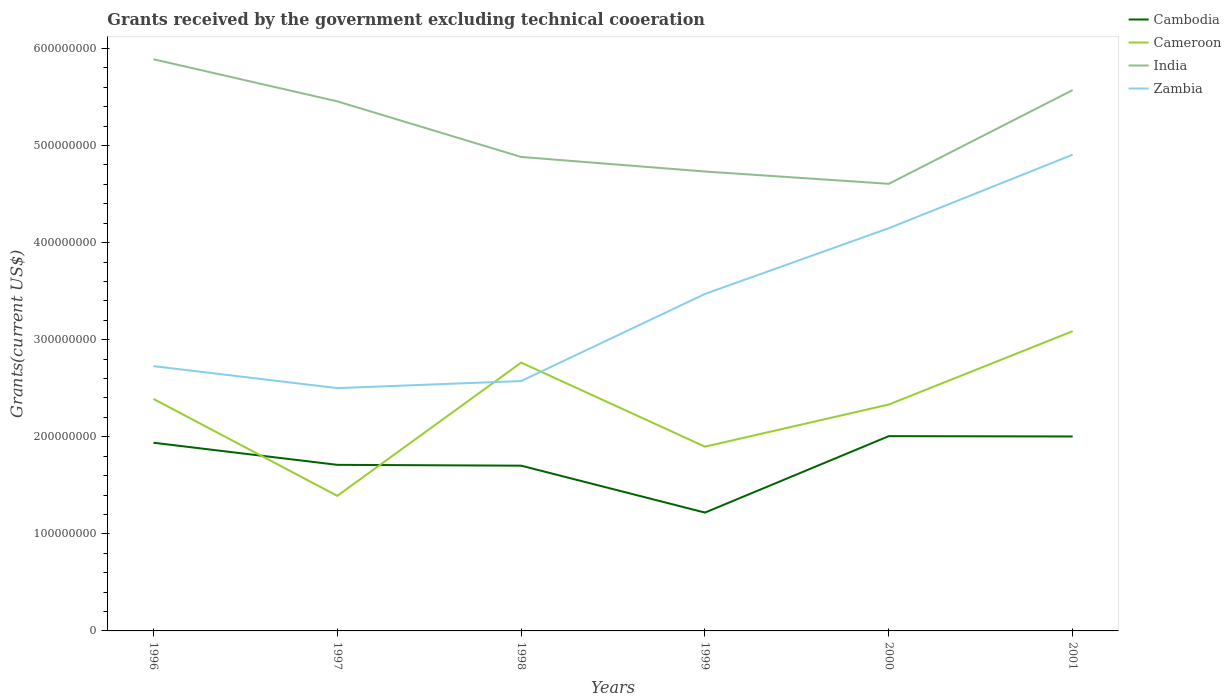How many different coloured lines are there?
Ensure brevity in your answer.  4. Does the line corresponding to India intersect with the line corresponding to Cambodia?
Provide a succinct answer. No. Across all years, what is the maximum total grants received by the government in Zambia?
Provide a short and direct response. 2.50e+08. In which year was the total grants received by the government in India maximum?
Your answer should be compact. 2000. What is the total total grants received by the government in India in the graph?
Provide a short and direct response. 8.50e+07. What is the difference between the highest and the second highest total grants received by the government in India?
Offer a very short reply. 1.28e+08. What is the difference between the highest and the lowest total grants received by the government in India?
Provide a succinct answer. 3. Is the total grants received by the government in Cameroon strictly greater than the total grants received by the government in Cambodia over the years?
Your answer should be very brief. No. How many years are there in the graph?
Offer a very short reply. 6. Where does the legend appear in the graph?
Provide a short and direct response. Top right. How many legend labels are there?
Provide a succinct answer. 4. What is the title of the graph?
Make the answer very short. Grants received by the government excluding technical cooeration. What is the label or title of the X-axis?
Your response must be concise. Years. What is the label or title of the Y-axis?
Your answer should be very brief. Grants(current US$). What is the Grants(current US$) of Cambodia in 1996?
Offer a very short reply. 1.94e+08. What is the Grants(current US$) in Cameroon in 1996?
Your answer should be compact. 2.39e+08. What is the Grants(current US$) of India in 1996?
Give a very brief answer. 5.89e+08. What is the Grants(current US$) of Zambia in 1996?
Provide a short and direct response. 2.73e+08. What is the Grants(current US$) in Cambodia in 1997?
Make the answer very short. 1.71e+08. What is the Grants(current US$) of Cameroon in 1997?
Your response must be concise. 1.39e+08. What is the Grants(current US$) of India in 1997?
Your answer should be compact. 5.46e+08. What is the Grants(current US$) of Zambia in 1997?
Your answer should be compact. 2.50e+08. What is the Grants(current US$) in Cambodia in 1998?
Offer a very short reply. 1.70e+08. What is the Grants(current US$) of Cameroon in 1998?
Keep it short and to the point. 2.76e+08. What is the Grants(current US$) in India in 1998?
Provide a succinct answer. 4.88e+08. What is the Grants(current US$) of Zambia in 1998?
Offer a very short reply. 2.57e+08. What is the Grants(current US$) in Cambodia in 1999?
Your response must be concise. 1.22e+08. What is the Grants(current US$) in Cameroon in 1999?
Your answer should be very brief. 1.90e+08. What is the Grants(current US$) of India in 1999?
Provide a succinct answer. 4.73e+08. What is the Grants(current US$) of Zambia in 1999?
Provide a short and direct response. 3.47e+08. What is the Grants(current US$) in Cambodia in 2000?
Provide a succinct answer. 2.01e+08. What is the Grants(current US$) in Cameroon in 2000?
Make the answer very short. 2.33e+08. What is the Grants(current US$) of India in 2000?
Make the answer very short. 4.61e+08. What is the Grants(current US$) in Zambia in 2000?
Offer a very short reply. 4.15e+08. What is the Grants(current US$) of Cambodia in 2001?
Give a very brief answer. 2.00e+08. What is the Grants(current US$) in Cameroon in 2001?
Provide a succinct answer. 3.09e+08. What is the Grants(current US$) of India in 2001?
Your response must be concise. 5.57e+08. What is the Grants(current US$) of Zambia in 2001?
Make the answer very short. 4.91e+08. Across all years, what is the maximum Grants(current US$) of Cambodia?
Ensure brevity in your answer.  2.01e+08. Across all years, what is the maximum Grants(current US$) of Cameroon?
Provide a short and direct response. 3.09e+08. Across all years, what is the maximum Grants(current US$) of India?
Keep it short and to the point. 5.89e+08. Across all years, what is the maximum Grants(current US$) of Zambia?
Make the answer very short. 4.91e+08. Across all years, what is the minimum Grants(current US$) in Cambodia?
Your answer should be compact. 1.22e+08. Across all years, what is the minimum Grants(current US$) of Cameroon?
Your answer should be very brief. 1.39e+08. Across all years, what is the minimum Grants(current US$) in India?
Provide a short and direct response. 4.61e+08. Across all years, what is the minimum Grants(current US$) of Zambia?
Offer a terse response. 2.50e+08. What is the total Grants(current US$) in Cambodia in the graph?
Keep it short and to the point. 1.06e+09. What is the total Grants(current US$) of Cameroon in the graph?
Give a very brief answer. 1.39e+09. What is the total Grants(current US$) in India in the graph?
Offer a very short reply. 3.11e+09. What is the total Grants(current US$) in Zambia in the graph?
Give a very brief answer. 2.03e+09. What is the difference between the Grants(current US$) of Cambodia in 1996 and that in 1997?
Your answer should be very brief. 2.28e+07. What is the difference between the Grants(current US$) of Cameroon in 1996 and that in 1997?
Provide a short and direct response. 9.99e+07. What is the difference between the Grants(current US$) of India in 1996 and that in 1997?
Offer a terse response. 4.34e+07. What is the difference between the Grants(current US$) in Zambia in 1996 and that in 1997?
Your answer should be compact. 2.27e+07. What is the difference between the Grants(current US$) of Cambodia in 1996 and that in 1998?
Give a very brief answer. 2.36e+07. What is the difference between the Grants(current US$) in Cameroon in 1996 and that in 1998?
Offer a very short reply. -3.74e+07. What is the difference between the Grants(current US$) of India in 1996 and that in 1998?
Provide a short and direct response. 1.01e+08. What is the difference between the Grants(current US$) of Zambia in 1996 and that in 1998?
Keep it short and to the point. 1.54e+07. What is the difference between the Grants(current US$) in Cambodia in 1996 and that in 1999?
Offer a very short reply. 7.20e+07. What is the difference between the Grants(current US$) in Cameroon in 1996 and that in 1999?
Your answer should be very brief. 4.92e+07. What is the difference between the Grants(current US$) of India in 1996 and that in 1999?
Make the answer very short. 1.16e+08. What is the difference between the Grants(current US$) of Zambia in 1996 and that in 1999?
Make the answer very short. -7.44e+07. What is the difference between the Grants(current US$) in Cambodia in 1996 and that in 2000?
Offer a terse response. -6.78e+06. What is the difference between the Grants(current US$) of Cameroon in 1996 and that in 2000?
Give a very brief answer. 5.79e+06. What is the difference between the Grants(current US$) of India in 1996 and that in 2000?
Give a very brief answer. 1.28e+08. What is the difference between the Grants(current US$) in Zambia in 1996 and that in 2000?
Offer a very short reply. -1.42e+08. What is the difference between the Grants(current US$) of Cambodia in 1996 and that in 2001?
Provide a short and direct response. -6.45e+06. What is the difference between the Grants(current US$) of Cameroon in 1996 and that in 2001?
Ensure brevity in your answer.  -6.98e+07. What is the difference between the Grants(current US$) in India in 1996 and that in 2001?
Provide a short and direct response. 3.18e+07. What is the difference between the Grants(current US$) in Zambia in 1996 and that in 2001?
Provide a short and direct response. -2.18e+08. What is the difference between the Grants(current US$) of Cambodia in 1997 and that in 1998?
Provide a succinct answer. 8.60e+05. What is the difference between the Grants(current US$) of Cameroon in 1997 and that in 1998?
Your answer should be compact. -1.37e+08. What is the difference between the Grants(current US$) of India in 1997 and that in 1998?
Give a very brief answer. 5.73e+07. What is the difference between the Grants(current US$) of Zambia in 1997 and that in 1998?
Offer a terse response. -7.27e+06. What is the difference between the Grants(current US$) in Cambodia in 1997 and that in 1999?
Give a very brief answer. 4.92e+07. What is the difference between the Grants(current US$) in Cameroon in 1997 and that in 1999?
Offer a very short reply. -5.07e+07. What is the difference between the Grants(current US$) of India in 1997 and that in 1999?
Make the answer very short. 7.23e+07. What is the difference between the Grants(current US$) in Zambia in 1997 and that in 1999?
Your answer should be compact. -9.70e+07. What is the difference between the Grants(current US$) of Cambodia in 1997 and that in 2000?
Make the answer very short. -2.96e+07. What is the difference between the Grants(current US$) in Cameroon in 1997 and that in 2000?
Provide a short and direct response. -9.41e+07. What is the difference between the Grants(current US$) of India in 1997 and that in 2000?
Make the answer very short. 8.50e+07. What is the difference between the Grants(current US$) in Zambia in 1997 and that in 2000?
Your answer should be very brief. -1.65e+08. What is the difference between the Grants(current US$) of Cambodia in 1997 and that in 2001?
Give a very brief answer. -2.92e+07. What is the difference between the Grants(current US$) of Cameroon in 1997 and that in 2001?
Give a very brief answer. -1.70e+08. What is the difference between the Grants(current US$) of India in 1997 and that in 2001?
Provide a short and direct response. -1.16e+07. What is the difference between the Grants(current US$) of Zambia in 1997 and that in 2001?
Your response must be concise. -2.40e+08. What is the difference between the Grants(current US$) of Cambodia in 1998 and that in 1999?
Keep it short and to the point. 4.83e+07. What is the difference between the Grants(current US$) of Cameroon in 1998 and that in 1999?
Provide a succinct answer. 8.66e+07. What is the difference between the Grants(current US$) of India in 1998 and that in 1999?
Ensure brevity in your answer.  1.50e+07. What is the difference between the Grants(current US$) in Zambia in 1998 and that in 1999?
Your response must be concise. -8.97e+07. What is the difference between the Grants(current US$) in Cambodia in 1998 and that in 2000?
Offer a very short reply. -3.04e+07. What is the difference between the Grants(current US$) in Cameroon in 1998 and that in 2000?
Offer a very short reply. 4.32e+07. What is the difference between the Grants(current US$) in India in 1998 and that in 2000?
Give a very brief answer. 2.77e+07. What is the difference between the Grants(current US$) of Zambia in 1998 and that in 2000?
Provide a short and direct response. -1.57e+08. What is the difference between the Grants(current US$) of Cambodia in 1998 and that in 2001?
Your response must be concise. -3.01e+07. What is the difference between the Grants(current US$) in Cameroon in 1998 and that in 2001?
Your response must be concise. -3.24e+07. What is the difference between the Grants(current US$) in India in 1998 and that in 2001?
Provide a short and direct response. -6.89e+07. What is the difference between the Grants(current US$) in Zambia in 1998 and that in 2001?
Keep it short and to the point. -2.33e+08. What is the difference between the Grants(current US$) of Cambodia in 1999 and that in 2000?
Provide a succinct answer. -7.87e+07. What is the difference between the Grants(current US$) of Cameroon in 1999 and that in 2000?
Offer a terse response. -4.34e+07. What is the difference between the Grants(current US$) in India in 1999 and that in 2000?
Your answer should be compact. 1.27e+07. What is the difference between the Grants(current US$) of Zambia in 1999 and that in 2000?
Offer a very short reply. -6.77e+07. What is the difference between the Grants(current US$) in Cambodia in 1999 and that in 2001?
Offer a terse response. -7.84e+07. What is the difference between the Grants(current US$) in Cameroon in 1999 and that in 2001?
Your response must be concise. -1.19e+08. What is the difference between the Grants(current US$) in India in 1999 and that in 2001?
Offer a terse response. -8.39e+07. What is the difference between the Grants(current US$) of Zambia in 1999 and that in 2001?
Your answer should be very brief. -1.43e+08. What is the difference between the Grants(current US$) of Cameroon in 2000 and that in 2001?
Provide a short and direct response. -7.55e+07. What is the difference between the Grants(current US$) in India in 2000 and that in 2001?
Your response must be concise. -9.66e+07. What is the difference between the Grants(current US$) of Zambia in 2000 and that in 2001?
Provide a succinct answer. -7.58e+07. What is the difference between the Grants(current US$) in Cambodia in 1996 and the Grants(current US$) in Cameroon in 1997?
Ensure brevity in your answer.  5.47e+07. What is the difference between the Grants(current US$) of Cambodia in 1996 and the Grants(current US$) of India in 1997?
Your response must be concise. -3.52e+08. What is the difference between the Grants(current US$) in Cambodia in 1996 and the Grants(current US$) in Zambia in 1997?
Ensure brevity in your answer.  -5.63e+07. What is the difference between the Grants(current US$) in Cameroon in 1996 and the Grants(current US$) in India in 1997?
Keep it short and to the point. -3.07e+08. What is the difference between the Grants(current US$) of Cameroon in 1996 and the Grants(current US$) of Zambia in 1997?
Make the answer very short. -1.11e+07. What is the difference between the Grants(current US$) in India in 1996 and the Grants(current US$) in Zambia in 1997?
Your answer should be very brief. 3.39e+08. What is the difference between the Grants(current US$) of Cambodia in 1996 and the Grants(current US$) of Cameroon in 1998?
Make the answer very short. -8.25e+07. What is the difference between the Grants(current US$) of Cambodia in 1996 and the Grants(current US$) of India in 1998?
Your response must be concise. -2.94e+08. What is the difference between the Grants(current US$) in Cambodia in 1996 and the Grants(current US$) in Zambia in 1998?
Offer a terse response. -6.35e+07. What is the difference between the Grants(current US$) in Cameroon in 1996 and the Grants(current US$) in India in 1998?
Provide a succinct answer. -2.49e+08. What is the difference between the Grants(current US$) in Cameroon in 1996 and the Grants(current US$) in Zambia in 1998?
Ensure brevity in your answer.  -1.84e+07. What is the difference between the Grants(current US$) of India in 1996 and the Grants(current US$) of Zambia in 1998?
Make the answer very short. 3.32e+08. What is the difference between the Grants(current US$) in Cambodia in 1996 and the Grants(current US$) in Cameroon in 1999?
Offer a terse response. 4.06e+06. What is the difference between the Grants(current US$) in Cambodia in 1996 and the Grants(current US$) in India in 1999?
Your response must be concise. -2.79e+08. What is the difference between the Grants(current US$) of Cambodia in 1996 and the Grants(current US$) of Zambia in 1999?
Your answer should be very brief. -1.53e+08. What is the difference between the Grants(current US$) in Cameroon in 1996 and the Grants(current US$) in India in 1999?
Provide a short and direct response. -2.34e+08. What is the difference between the Grants(current US$) of Cameroon in 1996 and the Grants(current US$) of Zambia in 1999?
Provide a succinct answer. -1.08e+08. What is the difference between the Grants(current US$) in India in 1996 and the Grants(current US$) in Zambia in 1999?
Keep it short and to the point. 2.42e+08. What is the difference between the Grants(current US$) in Cambodia in 1996 and the Grants(current US$) in Cameroon in 2000?
Your answer should be very brief. -3.94e+07. What is the difference between the Grants(current US$) of Cambodia in 1996 and the Grants(current US$) of India in 2000?
Offer a terse response. -2.67e+08. What is the difference between the Grants(current US$) in Cambodia in 1996 and the Grants(current US$) in Zambia in 2000?
Offer a terse response. -2.21e+08. What is the difference between the Grants(current US$) in Cameroon in 1996 and the Grants(current US$) in India in 2000?
Keep it short and to the point. -2.22e+08. What is the difference between the Grants(current US$) in Cameroon in 1996 and the Grants(current US$) in Zambia in 2000?
Provide a succinct answer. -1.76e+08. What is the difference between the Grants(current US$) of India in 1996 and the Grants(current US$) of Zambia in 2000?
Offer a terse response. 1.74e+08. What is the difference between the Grants(current US$) of Cambodia in 1996 and the Grants(current US$) of Cameroon in 2001?
Your answer should be compact. -1.15e+08. What is the difference between the Grants(current US$) in Cambodia in 1996 and the Grants(current US$) in India in 2001?
Your response must be concise. -3.63e+08. What is the difference between the Grants(current US$) of Cambodia in 1996 and the Grants(current US$) of Zambia in 2001?
Give a very brief answer. -2.97e+08. What is the difference between the Grants(current US$) of Cameroon in 1996 and the Grants(current US$) of India in 2001?
Make the answer very short. -3.18e+08. What is the difference between the Grants(current US$) of Cameroon in 1996 and the Grants(current US$) of Zambia in 2001?
Provide a short and direct response. -2.52e+08. What is the difference between the Grants(current US$) in India in 1996 and the Grants(current US$) in Zambia in 2001?
Offer a very short reply. 9.83e+07. What is the difference between the Grants(current US$) in Cambodia in 1997 and the Grants(current US$) in Cameroon in 1998?
Offer a very short reply. -1.05e+08. What is the difference between the Grants(current US$) in Cambodia in 1997 and the Grants(current US$) in India in 1998?
Provide a succinct answer. -3.17e+08. What is the difference between the Grants(current US$) of Cambodia in 1997 and the Grants(current US$) of Zambia in 1998?
Ensure brevity in your answer.  -8.63e+07. What is the difference between the Grants(current US$) in Cameroon in 1997 and the Grants(current US$) in India in 1998?
Your response must be concise. -3.49e+08. What is the difference between the Grants(current US$) of Cameroon in 1997 and the Grants(current US$) of Zambia in 1998?
Offer a terse response. -1.18e+08. What is the difference between the Grants(current US$) in India in 1997 and the Grants(current US$) in Zambia in 1998?
Ensure brevity in your answer.  2.88e+08. What is the difference between the Grants(current US$) in Cambodia in 1997 and the Grants(current US$) in Cameroon in 1999?
Provide a short and direct response. -1.87e+07. What is the difference between the Grants(current US$) of Cambodia in 1997 and the Grants(current US$) of India in 1999?
Give a very brief answer. -3.02e+08. What is the difference between the Grants(current US$) in Cambodia in 1997 and the Grants(current US$) in Zambia in 1999?
Ensure brevity in your answer.  -1.76e+08. What is the difference between the Grants(current US$) of Cameroon in 1997 and the Grants(current US$) of India in 1999?
Make the answer very short. -3.34e+08. What is the difference between the Grants(current US$) of Cameroon in 1997 and the Grants(current US$) of Zambia in 1999?
Offer a terse response. -2.08e+08. What is the difference between the Grants(current US$) of India in 1997 and the Grants(current US$) of Zambia in 1999?
Offer a very short reply. 1.98e+08. What is the difference between the Grants(current US$) in Cambodia in 1997 and the Grants(current US$) in Cameroon in 2000?
Offer a very short reply. -6.21e+07. What is the difference between the Grants(current US$) of Cambodia in 1997 and the Grants(current US$) of India in 2000?
Provide a succinct answer. -2.90e+08. What is the difference between the Grants(current US$) in Cambodia in 1997 and the Grants(current US$) in Zambia in 2000?
Ensure brevity in your answer.  -2.44e+08. What is the difference between the Grants(current US$) of Cameroon in 1997 and the Grants(current US$) of India in 2000?
Your answer should be compact. -3.21e+08. What is the difference between the Grants(current US$) in Cameroon in 1997 and the Grants(current US$) in Zambia in 2000?
Ensure brevity in your answer.  -2.76e+08. What is the difference between the Grants(current US$) in India in 1997 and the Grants(current US$) in Zambia in 2000?
Your response must be concise. 1.31e+08. What is the difference between the Grants(current US$) of Cambodia in 1997 and the Grants(current US$) of Cameroon in 2001?
Provide a succinct answer. -1.38e+08. What is the difference between the Grants(current US$) in Cambodia in 1997 and the Grants(current US$) in India in 2001?
Keep it short and to the point. -3.86e+08. What is the difference between the Grants(current US$) of Cambodia in 1997 and the Grants(current US$) of Zambia in 2001?
Provide a succinct answer. -3.20e+08. What is the difference between the Grants(current US$) in Cameroon in 1997 and the Grants(current US$) in India in 2001?
Your answer should be very brief. -4.18e+08. What is the difference between the Grants(current US$) of Cameroon in 1997 and the Grants(current US$) of Zambia in 2001?
Your answer should be compact. -3.51e+08. What is the difference between the Grants(current US$) in India in 1997 and the Grants(current US$) in Zambia in 2001?
Keep it short and to the point. 5.49e+07. What is the difference between the Grants(current US$) in Cambodia in 1998 and the Grants(current US$) in Cameroon in 1999?
Make the answer very short. -1.96e+07. What is the difference between the Grants(current US$) of Cambodia in 1998 and the Grants(current US$) of India in 1999?
Offer a terse response. -3.03e+08. What is the difference between the Grants(current US$) of Cambodia in 1998 and the Grants(current US$) of Zambia in 1999?
Make the answer very short. -1.77e+08. What is the difference between the Grants(current US$) in Cameroon in 1998 and the Grants(current US$) in India in 1999?
Offer a terse response. -1.97e+08. What is the difference between the Grants(current US$) of Cameroon in 1998 and the Grants(current US$) of Zambia in 1999?
Your answer should be compact. -7.07e+07. What is the difference between the Grants(current US$) in India in 1998 and the Grants(current US$) in Zambia in 1999?
Your response must be concise. 1.41e+08. What is the difference between the Grants(current US$) of Cambodia in 1998 and the Grants(current US$) of Cameroon in 2000?
Provide a short and direct response. -6.30e+07. What is the difference between the Grants(current US$) of Cambodia in 1998 and the Grants(current US$) of India in 2000?
Make the answer very short. -2.90e+08. What is the difference between the Grants(current US$) of Cambodia in 1998 and the Grants(current US$) of Zambia in 2000?
Make the answer very short. -2.45e+08. What is the difference between the Grants(current US$) of Cameroon in 1998 and the Grants(current US$) of India in 2000?
Offer a very short reply. -1.84e+08. What is the difference between the Grants(current US$) of Cameroon in 1998 and the Grants(current US$) of Zambia in 2000?
Your answer should be compact. -1.38e+08. What is the difference between the Grants(current US$) of India in 1998 and the Grants(current US$) of Zambia in 2000?
Offer a very short reply. 7.34e+07. What is the difference between the Grants(current US$) in Cambodia in 1998 and the Grants(current US$) in Cameroon in 2001?
Provide a short and direct response. -1.39e+08. What is the difference between the Grants(current US$) of Cambodia in 1998 and the Grants(current US$) of India in 2001?
Offer a very short reply. -3.87e+08. What is the difference between the Grants(current US$) of Cambodia in 1998 and the Grants(current US$) of Zambia in 2001?
Make the answer very short. -3.20e+08. What is the difference between the Grants(current US$) of Cameroon in 1998 and the Grants(current US$) of India in 2001?
Keep it short and to the point. -2.81e+08. What is the difference between the Grants(current US$) in Cameroon in 1998 and the Grants(current US$) in Zambia in 2001?
Your answer should be compact. -2.14e+08. What is the difference between the Grants(current US$) in India in 1998 and the Grants(current US$) in Zambia in 2001?
Offer a very short reply. -2.36e+06. What is the difference between the Grants(current US$) in Cambodia in 1999 and the Grants(current US$) in Cameroon in 2000?
Ensure brevity in your answer.  -1.11e+08. What is the difference between the Grants(current US$) of Cambodia in 1999 and the Grants(current US$) of India in 2000?
Your response must be concise. -3.39e+08. What is the difference between the Grants(current US$) in Cambodia in 1999 and the Grants(current US$) in Zambia in 2000?
Your answer should be compact. -2.93e+08. What is the difference between the Grants(current US$) in Cameroon in 1999 and the Grants(current US$) in India in 2000?
Make the answer very short. -2.71e+08. What is the difference between the Grants(current US$) in Cameroon in 1999 and the Grants(current US$) in Zambia in 2000?
Your answer should be compact. -2.25e+08. What is the difference between the Grants(current US$) in India in 1999 and the Grants(current US$) in Zambia in 2000?
Provide a succinct answer. 5.84e+07. What is the difference between the Grants(current US$) in Cambodia in 1999 and the Grants(current US$) in Cameroon in 2001?
Offer a very short reply. -1.87e+08. What is the difference between the Grants(current US$) in Cambodia in 1999 and the Grants(current US$) in India in 2001?
Ensure brevity in your answer.  -4.35e+08. What is the difference between the Grants(current US$) in Cambodia in 1999 and the Grants(current US$) in Zambia in 2001?
Offer a very short reply. -3.69e+08. What is the difference between the Grants(current US$) in Cameroon in 1999 and the Grants(current US$) in India in 2001?
Offer a terse response. -3.67e+08. What is the difference between the Grants(current US$) of Cameroon in 1999 and the Grants(current US$) of Zambia in 2001?
Your response must be concise. -3.01e+08. What is the difference between the Grants(current US$) of India in 1999 and the Grants(current US$) of Zambia in 2001?
Offer a very short reply. -1.74e+07. What is the difference between the Grants(current US$) in Cambodia in 2000 and the Grants(current US$) in Cameroon in 2001?
Keep it short and to the point. -1.08e+08. What is the difference between the Grants(current US$) of Cambodia in 2000 and the Grants(current US$) of India in 2001?
Your answer should be very brief. -3.57e+08. What is the difference between the Grants(current US$) of Cambodia in 2000 and the Grants(current US$) of Zambia in 2001?
Ensure brevity in your answer.  -2.90e+08. What is the difference between the Grants(current US$) of Cameroon in 2000 and the Grants(current US$) of India in 2001?
Offer a very short reply. -3.24e+08. What is the difference between the Grants(current US$) in Cameroon in 2000 and the Grants(current US$) in Zambia in 2001?
Provide a short and direct response. -2.57e+08. What is the difference between the Grants(current US$) in India in 2000 and the Grants(current US$) in Zambia in 2001?
Make the answer very short. -3.00e+07. What is the average Grants(current US$) of Cambodia per year?
Your answer should be compact. 1.76e+08. What is the average Grants(current US$) in Cameroon per year?
Offer a very short reply. 2.31e+08. What is the average Grants(current US$) of India per year?
Keep it short and to the point. 5.19e+08. What is the average Grants(current US$) in Zambia per year?
Provide a succinct answer. 3.39e+08. In the year 1996, what is the difference between the Grants(current US$) in Cambodia and Grants(current US$) in Cameroon?
Offer a terse response. -4.51e+07. In the year 1996, what is the difference between the Grants(current US$) in Cambodia and Grants(current US$) in India?
Your response must be concise. -3.95e+08. In the year 1996, what is the difference between the Grants(current US$) in Cambodia and Grants(current US$) in Zambia?
Provide a succinct answer. -7.89e+07. In the year 1996, what is the difference between the Grants(current US$) of Cameroon and Grants(current US$) of India?
Ensure brevity in your answer.  -3.50e+08. In the year 1996, what is the difference between the Grants(current US$) of Cameroon and Grants(current US$) of Zambia?
Give a very brief answer. -3.38e+07. In the year 1996, what is the difference between the Grants(current US$) in India and Grants(current US$) in Zambia?
Give a very brief answer. 3.16e+08. In the year 1997, what is the difference between the Grants(current US$) in Cambodia and Grants(current US$) in Cameroon?
Provide a short and direct response. 3.19e+07. In the year 1997, what is the difference between the Grants(current US$) of Cambodia and Grants(current US$) of India?
Give a very brief answer. -3.74e+08. In the year 1997, what is the difference between the Grants(current US$) of Cambodia and Grants(current US$) of Zambia?
Your answer should be compact. -7.90e+07. In the year 1997, what is the difference between the Grants(current US$) in Cameroon and Grants(current US$) in India?
Your answer should be compact. -4.06e+08. In the year 1997, what is the difference between the Grants(current US$) in Cameroon and Grants(current US$) in Zambia?
Give a very brief answer. -1.11e+08. In the year 1997, what is the difference between the Grants(current US$) of India and Grants(current US$) of Zambia?
Ensure brevity in your answer.  2.95e+08. In the year 1998, what is the difference between the Grants(current US$) of Cambodia and Grants(current US$) of Cameroon?
Offer a very short reply. -1.06e+08. In the year 1998, what is the difference between the Grants(current US$) in Cambodia and Grants(current US$) in India?
Your answer should be compact. -3.18e+08. In the year 1998, what is the difference between the Grants(current US$) of Cambodia and Grants(current US$) of Zambia?
Make the answer very short. -8.72e+07. In the year 1998, what is the difference between the Grants(current US$) of Cameroon and Grants(current US$) of India?
Your answer should be very brief. -2.12e+08. In the year 1998, what is the difference between the Grants(current US$) of Cameroon and Grants(current US$) of Zambia?
Provide a succinct answer. 1.90e+07. In the year 1998, what is the difference between the Grants(current US$) of India and Grants(current US$) of Zambia?
Give a very brief answer. 2.31e+08. In the year 1999, what is the difference between the Grants(current US$) in Cambodia and Grants(current US$) in Cameroon?
Keep it short and to the point. -6.79e+07. In the year 1999, what is the difference between the Grants(current US$) of Cambodia and Grants(current US$) of India?
Provide a short and direct response. -3.51e+08. In the year 1999, what is the difference between the Grants(current US$) in Cambodia and Grants(current US$) in Zambia?
Make the answer very short. -2.25e+08. In the year 1999, what is the difference between the Grants(current US$) in Cameroon and Grants(current US$) in India?
Your response must be concise. -2.83e+08. In the year 1999, what is the difference between the Grants(current US$) of Cameroon and Grants(current US$) of Zambia?
Your response must be concise. -1.57e+08. In the year 1999, what is the difference between the Grants(current US$) of India and Grants(current US$) of Zambia?
Offer a very short reply. 1.26e+08. In the year 2000, what is the difference between the Grants(current US$) of Cambodia and Grants(current US$) of Cameroon?
Offer a very short reply. -3.26e+07. In the year 2000, what is the difference between the Grants(current US$) in Cambodia and Grants(current US$) in India?
Offer a very short reply. -2.60e+08. In the year 2000, what is the difference between the Grants(current US$) in Cambodia and Grants(current US$) in Zambia?
Give a very brief answer. -2.14e+08. In the year 2000, what is the difference between the Grants(current US$) of Cameroon and Grants(current US$) of India?
Your answer should be very brief. -2.27e+08. In the year 2000, what is the difference between the Grants(current US$) in Cameroon and Grants(current US$) in Zambia?
Offer a terse response. -1.82e+08. In the year 2000, what is the difference between the Grants(current US$) of India and Grants(current US$) of Zambia?
Offer a terse response. 4.57e+07. In the year 2001, what is the difference between the Grants(current US$) of Cambodia and Grants(current US$) of Cameroon?
Offer a terse response. -1.08e+08. In the year 2001, what is the difference between the Grants(current US$) in Cambodia and Grants(current US$) in India?
Give a very brief answer. -3.57e+08. In the year 2001, what is the difference between the Grants(current US$) of Cambodia and Grants(current US$) of Zambia?
Your answer should be very brief. -2.90e+08. In the year 2001, what is the difference between the Grants(current US$) in Cameroon and Grants(current US$) in India?
Give a very brief answer. -2.48e+08. In the year 2001, what is the difference between the Grants(current US$) of Cameroon and Grants(current US$) of Zambia?
Your answer should be very brief. -1.82e+08. In the year 2001, what is the difference between the Grants(current US$) of India and Grants(current US$) of Zambia?
Your answer should be very brief. 6.65e+07. What is the ratio of the Grants(current US$) in Cambodia in 1996 to that in 1997?
Offer a very short reply. 1.13. What is the ratio of the Grants(current US$) in Cameroon in 1996 to that in 1997?
Offer a very short reply. 1.72. What is the ratio of the Grants(current US$) of India in 1996 to that in 1997?
Your answer should be compact. 1.08. What is the ratio of the Grants(current US$) of Zambia in 1996 to that in 1997?
Offer a very short reply. 1.09. What is the ratio of the Grants(current US$) in Cambodia in 1996 to that in 1998?
Offer a very short reply. 1.14. What is the ratio of the Grants(current US$) of Cameroon in 1996 to that in 1998?
Your response must be concise. 0.86. What is the ratio of the Grants(current US$) of India in 1996 to that in 1998?
Keep it short and to the point. 1.21. What is the ratio of the Grants(current US$) of Zambia in 1996 to that in 1998?
Your response must be concise. 1.06. What is the ratio of the Grants(current US$) of Cambodia in 1996 to that in 1999?
Offer a terse response. 1.59. What is the ratio of the Grants(current US$) in Cameroon in 1996 to that in 1999?
Make the answer very short. 1.26. What is the ratio of the Grants(current US$) in India in 1996 to that in 1999?
Your answer should be compact. 1.24. What is the ratio of the Grants(current US$) in Zambia in 1996 to that in 1999?
Keep it short and to the point. 0.79. What is the ratio of the Grants(current US$) in Cambodia in 1996 to that in 2000?
Give a very brief answer. 0.97. What is the ratio of the Grants(current US$) of Cameroon in 1996 to that in 2000?
Offer a terse response. 1.02. What is the ratio of the Grants(current US$) of India in 1996 to that in 2000?
Your answer should be compact. 1.28. What is the ratio of the Grants(current US$) of Zambia in 1996 to that in 2000?
Give a very brief answer. 0.66. What is the ratio of the Grants(current US$) in Cambodia in 1996 to that in 2001?
Offer a terse response. 0.97. What is the ratio of the Grants(current US$) of Cameroon in 1996 to that in 2001?
Ensure brevity in your answer.  0.77. What is the ratio of the Grants(current US$) in India in 1996 to that in 2001?
Make the answer very short. 1.06. What is the ratio of the Grants(current US$) in Zambia in 1996 to that in 2001?
Your response must be concise. 0.56. What is the ratio of the Grants(current US$) of Cambodia in 1997 to that in 1998?
Provide a short and direct response. 1.01. What is the ratio of the Grants(current US$) of Cameroon in 1997 to that in 1998?
Your answer should be very brief. 0.5. What is the ratio of the Grants(current US$) in India in 1997 to that in 1998?
Your answer should be very brief. 1.12. What is the ratio of the Grants(current US$) of Zambia in 1997 to that in 1998?
Provide a succinct answer. 0.97. What is the ratio of the Grants(current US$) in Cambodia in 1997 to that in 1999?
Ensure brevity in your answer.  1.4. What is the ratio of the Grants(current US$) in Cameroon in 1997 to that in 1999?
Give a very brief answer. 0.73. What is the ratio of the Grants(current US$) of India in 1997 to that in 1999?
Your answer should be compact. 1.15. What is the ratio of the Grants(current US$) in Zambia in 1997 to that in 1999?
Provide a short and direct response. 0.72. What is the ratio of the Grants(current US$) of Cambodia in 1997 to that in 2000?
Offer a terse response. 0.85. What is the ratio of the Grants(current US$) in Cameroon in 1997 to that in 2000?
Your response must be concise. 0.6. What is the ratio of the Grants(current US$) in India in 1997 to that in 2000?
Ensure brevity in your answer.  1.18. What is the ratio of the Grants(current US$) of Zambia in 1997 to that in 2000?
Your answer should be very brief. 0.6. What is the ratio of the Grants(current US$) in Cambodia in 1997 to that in 2001?
Your answer should be compact. 0.85. What is the ratio of the Grants(current US$) in Cameroon in 1997 to that in 2001?
Make the answer very short. 0.45. What is the ratio of the Grants(current US$) of India in 1997 to that in 2001?
Provide a short and direct response. 0.98. What is the ratio of the Grants(current US$) of Zambia in 1997 to that in 2001?
Give a very brief answer. 0.51. What is the ratio of the Grants(current US$) in Cambodia in 1998 to that in 1999?
Offer a very short reply. 1.4. What is the ratio of the Grants(current US$) of Cameroon in 1998 to that in 1999?
Give a very brief answer. 1.46. What is the ratio of the Grants(current US$) in India in 1998 to that in 1999?
Your response must be concise. 1.03. What is the ratio of the Grants(current US$) of Zambia in 1998 to that in 1999?
Make the answer very short. 0.74. What is the ratio of the Grants(current US$) of Cambodia in 1998 to that in 2000?
Keep it short and to the point. 0.85. What is the ratio of the Grants(current US$) of Cameroon in 1998 to that in 2000?
Ensure brevity in your answer.  1.19. What is the ratio of the Grants(current US$) in India in 1998 to that in 2000?
Your response must be concise. 1.06. What is the ratio of the Grants(current US$) of Zambia in 1998 to that in 2000?
Offer a very short reply. 0.62. What is the ratio of the Grants(current US$) in Cambodia in 1998 to that in 2001?
Provide a short and direct response. 0.85. What is the ratio of the Grants(current US$) in Cameroon in 1998 to that in 2001?
Keep it short and to the point. 0.9. What is the ratio of the Grants(current US$) of India in 1998 to that in 2001?
Your answer should be very brief. 0.88. What is the ratio of the Grants(current US$) of Zambia in 1998 to that in 2001?
Provide a short and direct response. 0.52. What is the ratio of the Grants(current US$) in Cambodia in 1999 to that in 2000?
Offer a very short reply. 0.61. What is the ratio of the Grants(current US$) of Cameroon in 1999 to that in 2000?
Give a very brief answer. 0.81. What is the ratio of the Grants(current US$) of India in 1999 to that in 2000?
Provide a succinct answer. 1.03. What is the ratio of the Grants(current US$) in Zambia in 1999 to that in 2000?
Your response must be concise. 0.84. What is the ratio of the Grants(current US$) in Cambodia in 1999 to that in 2001?
Your answer should be compact. 0.61. What is the ratio of the Grants(current US$) in Cameroon in 1999 to that in 2001?
Ensure brevity in your answer.  0.61. What is the ratio of the Grants(current US$) in India in 1999 to that in 2001?
Ensure brevity in your answer.  0.85. What is the ratio of the Grants(current US$) in Zambia in 1999 to that in 2001?
Your answer should be very brief. 0.71. What is the ratio of the Grants(current US$) of Cameroon in 2000 to that in 2001?
Your answer should be compact. 0.76. What is the ratio of the Grants(current US$) of India in 2000 to that in 2001?
Give a very brief answer. 0.83. What is the ratio of the Grants(current US$) of Zambia in 2000 to that in 2001?
Ensure brevity in your answer.  0.85. What is the difference between the highest and the second highest Grants(current US$) of Cameroon?
Offer a very short reply. 3.24e+07. What is the difference between the highest and the second highest Grants(current US$) of India?
Your answer should be compact. 3.18e+07. What is the difference between the highest and the second highest Grants(current US$) in Zambia?
Keep it short and to the point. 7.58e+07. What is the difference between the highest and the lowest Grants(current US$) of Cambodia?
Offer a terse response. 7.87e+07. What is the difference between the highest and the lowest Grants(current US$) of Cameroon?
Keep it short and to the point. 1.70e+08. What is the difference between the highest and the lowest Grants(current US$) of India?
Offer a very short reply. 1.28e+08. What is the difference between the highest and the lowest Grants(current US$) in Zambia?
Keep it short and to the point. 2.40e+08. 